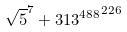Convert formula to latex. <formula><loc_0><loc_0><loc_500><loc_500>\sqrt { 5 } ^ { 7 } + { 3 1 3 ^ { 4 8 8 } } ^ { 2 2 6 }</formula> 